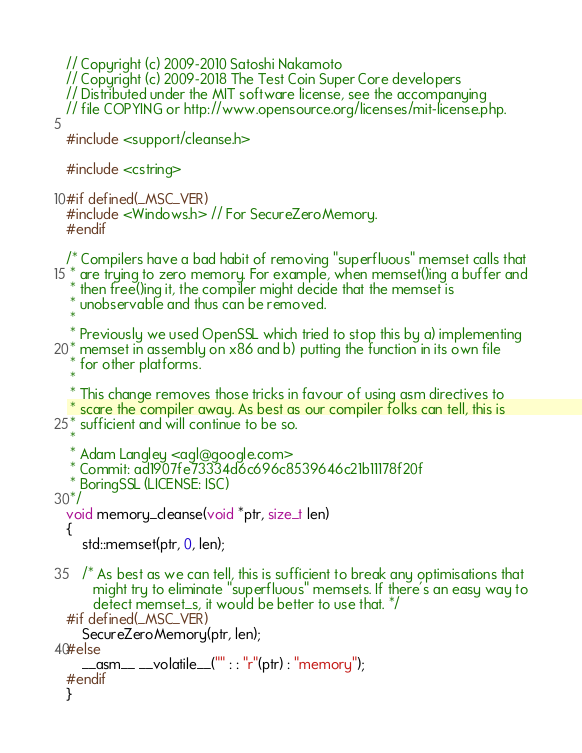<code> <loc_0><loc_0><loc_500><loc_500><_C++_>// Copyright (c) 2009-2010 Satoshi Nakamoto
// Copyright (c) 2009-2018 The Test Coin Super Core developers
// Distributed under the MIT software license, see the accompanying
// file COPYING or http://www.opensource.org/licenses/mit-license.php.

#include <support/cleanse.h>

#include <cstring>

#if defined(_MSC_VER)
#include <Windows.h> // For SecureZeroMemory.
#endif

/* Compilers have a bad habit of removing "superfluous" memset calls that
 * are trying to zero memory. For example, when memset()ing a buffer and
 * then free()ing it, the compiler might decide that the memset is
 * unobservable and thus can be removed.
 *
 * Previously we used OpenSSL which tried to stop this by a) implementing
 * memset in assembly on x86 and b) putting the function in its own file
 * for other platforms.
 *
 * This change removes those tricks in favour of using asm directives to
 * scare the compiler away. As best as our compiler folks can tell, this is
 * sufficient and will continue to be so.
 *
 * Adam Langley <agl@google.com>
 * Commit: ad1907fe73334d6c696c8539646c21b11178f20f
 * BoringSSL (LICENSE: ISC)
 */
void memory_cleanse(void *ptr, size_t len)
{
    std::memset(ptr, 0, len);

    /* As best as we can tell, this is sufficient to break any optimisations that
       might try to eliminate "superfluous" memsets. If there's an easy way to
       detect memset_s, it would be better to use that. */
#if defined(_MSC_VER)
    SecureZeroMemory(ptr, len);
#else
    __asm__ __volatile__("" : : "r"(ptr) : "memory");
#endif
}
</code> 